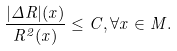<formula> <loc_0><loc_0><loc_500><loc_500>\frac { | \Delta R | ( x ) } { R ^ { 2 } ( x ) } \leq C , \forall x \in M .</formula> 